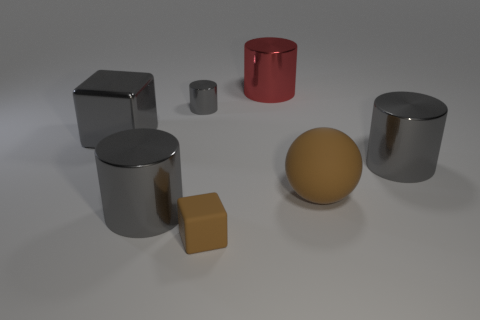There is a ball that is the same color as the tiny matte block; what material is it?
Provide a short and direct response. Rubber. Are there more brown rubber blocks behind the large brown rubber ball than tiny rubber things in front of the large red metallic thing?
Your response must be concise. No. What size is the brown rubber cube?
Your answer should be compact. Small. Do the small object that is in front of the large gray metallic block and the sphere have the same color?
Your response must be concise. Yes. Is there any other thing that has the same shape as the big rubber thing?
Ensure brevity in your answer.  No. There is a small thing that is in front of the large gray metallic cube; is there a large object that is left of it?
Offer a very short reply. Yes. Is the number of gray metal cylinders behind the brown matte sphere less than the number of big metallic blocks behind the big red shiny thing?
Your response must be concise. No. What size is the block in front of the big gray thing that is behind the gray cylinder to the right of the small matte thing?
Give a very brief answer. Small. Do the gray shiny cylinder that is right of the red metal thing and the brown matte sphere have the same size?
Offer a terse response. Yes. How many other objects are there of the same material as the tiny gray thing?
Make the answer very short. 4. 